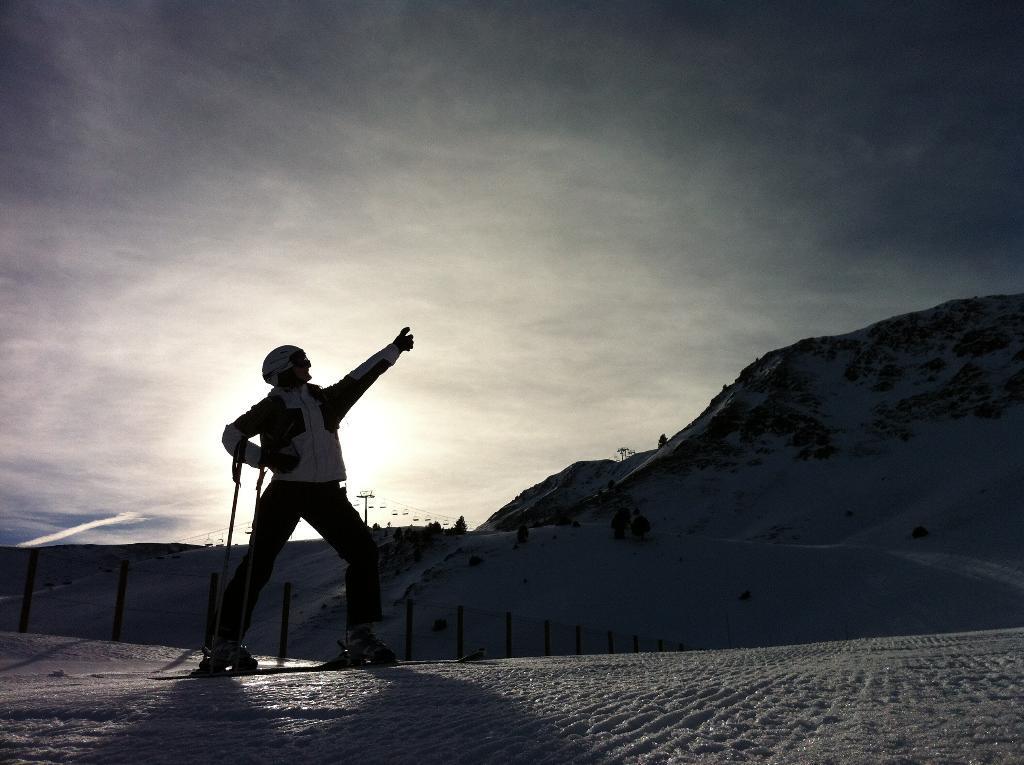Please provide a concise description of this image. a person is standing and raising his hand. there is snow everywhere around him. 